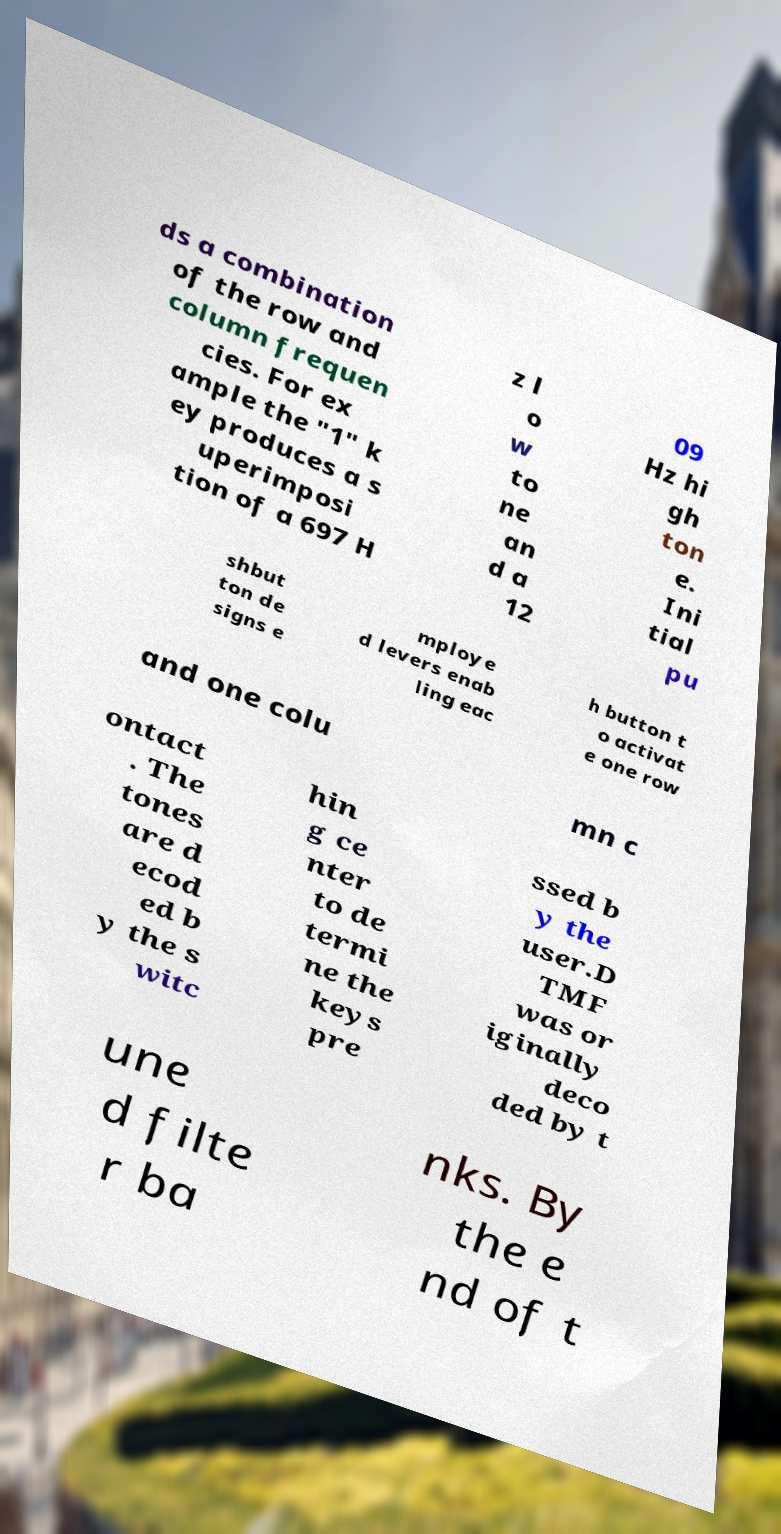Could you assist in decoding the text presented in this image and type it out clearly? ds a combination of the row and column frequen cies. For ex ample the "1" k ey produces a s uperimposi tion of a 697 H z l o w to ne an d a 12 09 Hz hi gh ton e. Ini tial pu shbut ton de signs e mploye d levers enab ling eac h button t o activat e one row and one colu mn c ontact . The tones are d ecod ed b y the s witc hin g ce nter to de termi ne the keys pre ssed b y the user.D TMF was or iginally deco ded by t une d filte r ba nks. By the e nd of t 